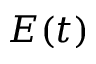<formula> <loc_0><loc_0><loc_500><loc_500>E ( t )</formula> 